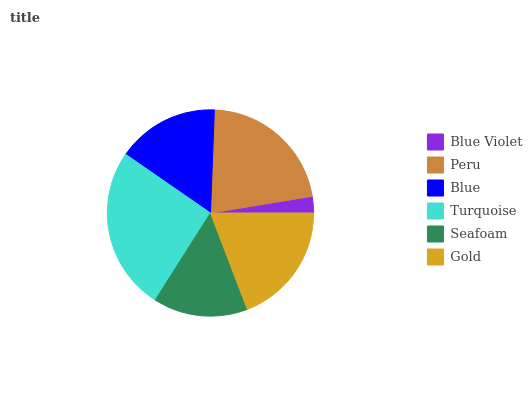Is Blue Violet the minimum?
Answer yes or no. Yes. Is Turquoise the maximum?
Answer yes or no. Yes. Is Peru the minimum?
Answer yes or no. No. Is Peru the maximum?
Answer yes or no. No. Is Peru greater than Blue Violet?
Answer yes or no. Yes. Is Blue Violet less than Peru?
Answer yes or no. Yes. Is Blue Violet greater than Peru?
Answer yes or no. No. Is Peru less than Blue Violet?
Answer yes or no. No. Is Gold the high median?
Answer yes or no. Yes. Is Blue the low median?
Answer yes or no. Yes. Is Peru the high median?
Answer yes or no. No. Is Gold the low median?
Answer yes or no. No. 